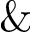Convert formula to latex. <formula><loc_0><loc_0><loc_500><loc_500>\&</formula> 